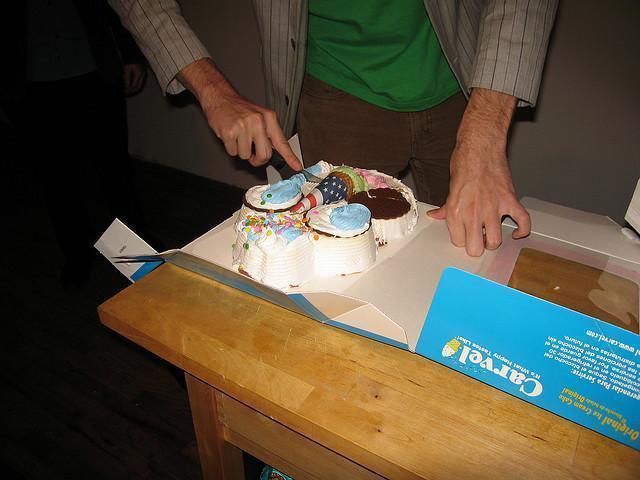What cool treat can be found inside this cake?
Indicate the correct choice and explain in the format: 'Answer: answer
Rationale: rationale.'
Options: Ice cream, ice, nothing, lava. Answer: ice cream.
Rationale: The cake was bought at carvel, which is an ice cream shop that sells ice cream cakes. 